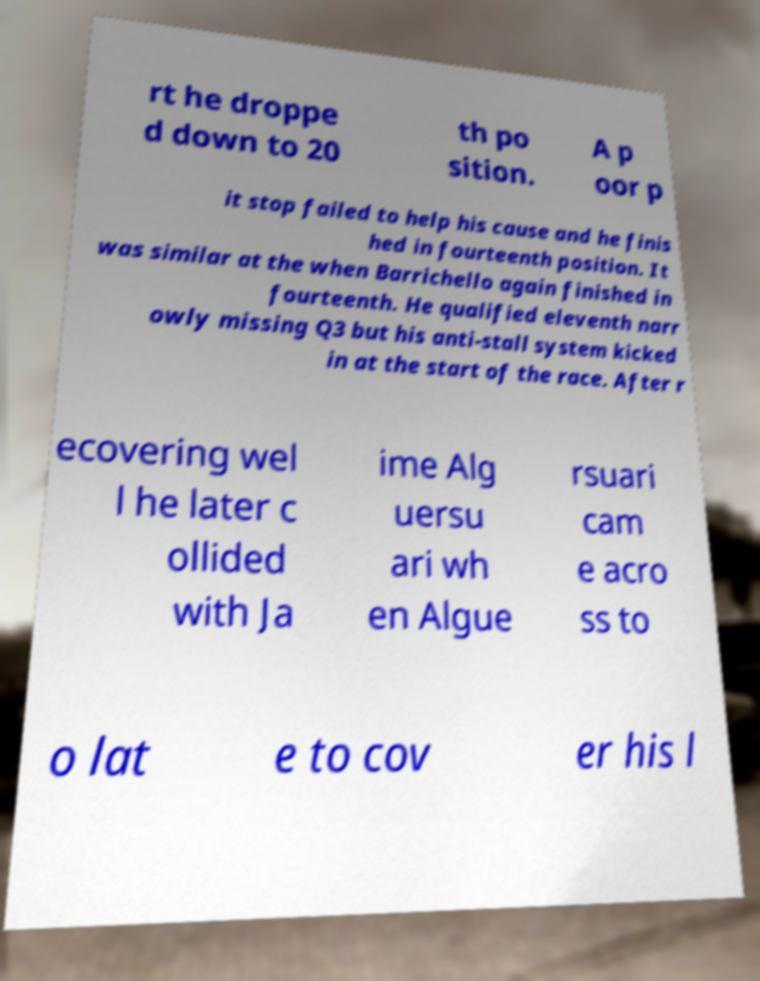For documentation purposes, I need the text within this image transcribed. Could you provide that? rt he droppe d down to 20 th po sition. A p oor p it stop failed to help his cause and he finis hed in fourteenth position. It was similar at the when Barrichello again finished in fourteenth. He qualified eleventh narr owly missing Q3 but his anti-stall system kicked in at the start of the race. After r ecovering wel l he later c ollided with Ja ime Alg uersu ari wh en Algue rsuari cam e acro ss to o lat e to cov er his l 